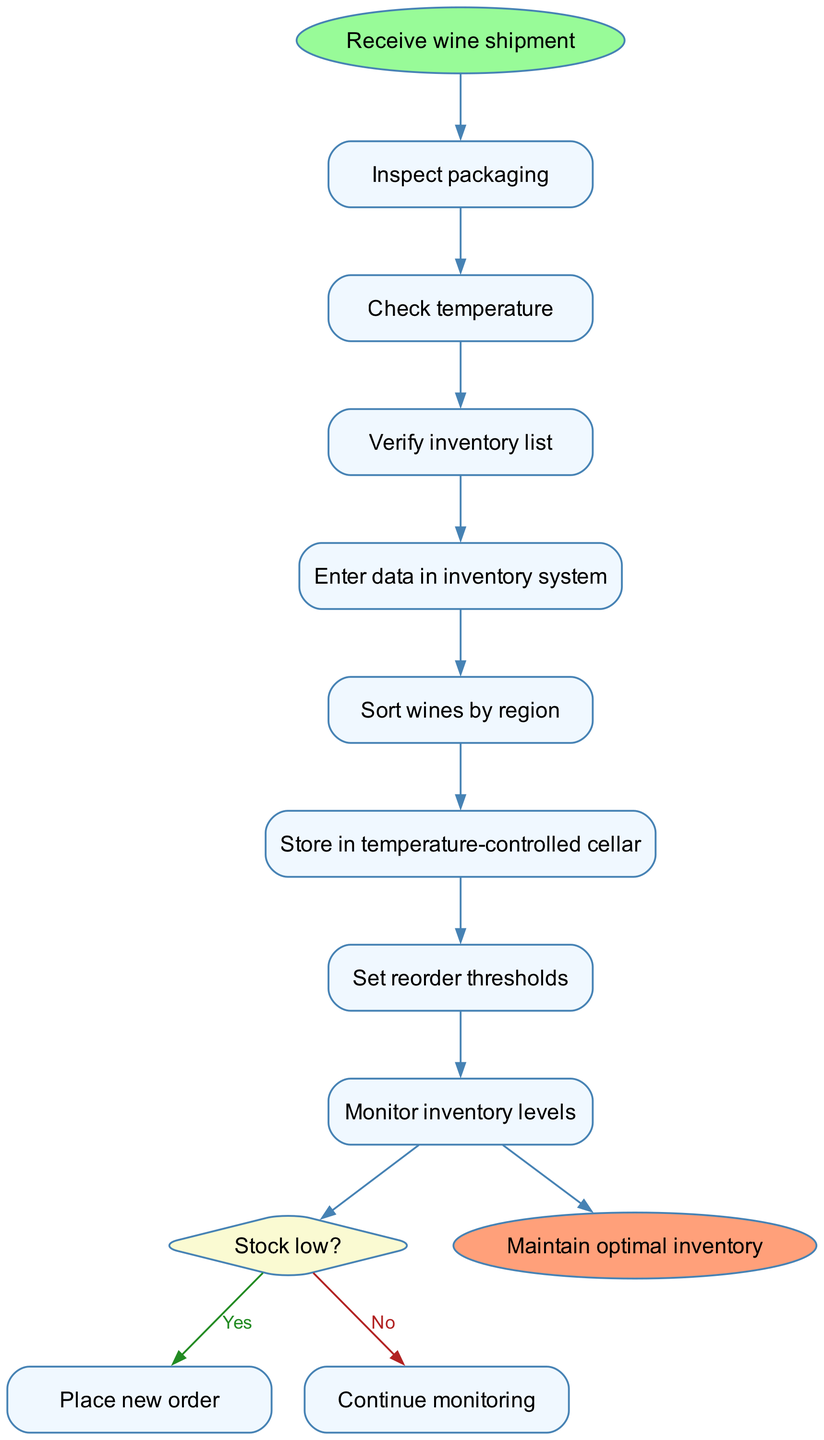What is the first action in the diagram? The diagram starts with the node labeled "Receive wine shipment," indicating the first action in the sequence.
Answer: Receive wine shipment How many steps are there in the process? The diagram lists eight steps involved in the wine storage and inventory management procedures.
Answer: Eight What comes after "Sort wines by region"? Following "Sort wines by region," the next action in the diagram is "Store in temperature-controlled cellar."
Answer: Store in temperature-controlled cellar What decision is made in the process? The process includes a decision labeled "Stock low?" which determines if a new order needs to be placed based on inventory levels.
Answer: Stock low? What action follows the "Place new order" decision? After "Place new order," the workflow ends with the action leading to "Maintain optimal inventory," indicating a return to the beginning of monitoring inventory levels.
Answer: Maintain optimal inventory What color represents the decision node in the diagram? The decision node is represented in a diamond shape with the fill color set to a light yellowish shade called "#FAFAD2."
Answer: Light yellow What is the last action completed in this flow chart? The final action completed in the flow chart is "Maintain optimal inventory," marking the end of the procedures outlined.
Answer: Maintain optimal inventory What action is taken after "Monitor inventory levels" if stock is low? If stock is low, the action taken next is "Place new order," indicating that action is needed to replenish stock.
Answer: Place new order What action precedes entering data in the inventory system? The action that comes before "Enter data in inventory system" is "Verify inventory list," as the process flows sequentially from step to step.
Answer: Verify inventory list 